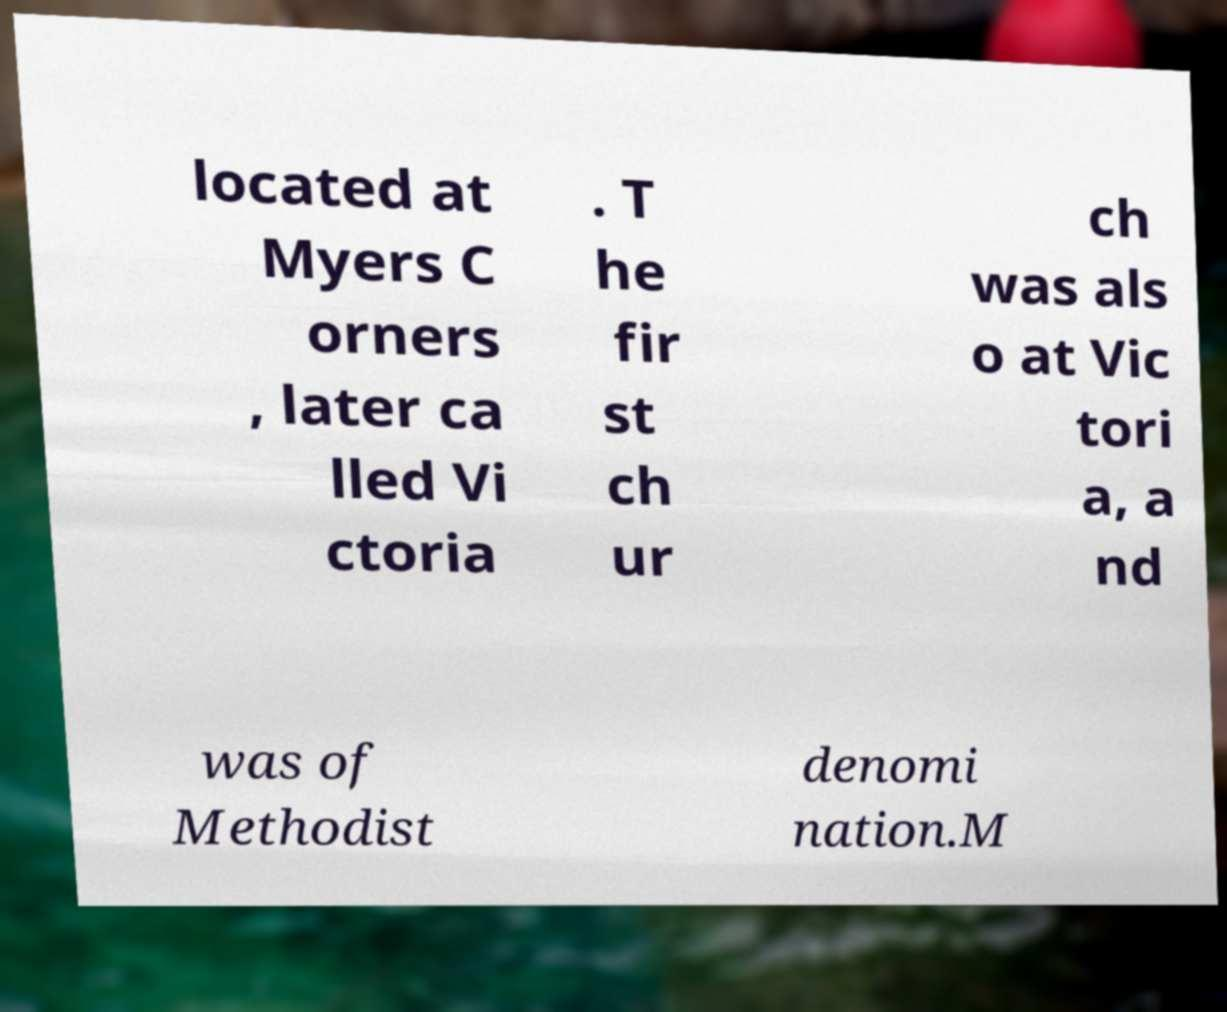There's text embedded in this image that I need extracted. Can you transcribe it verbatim? located at Myers C orners , later ca lled Vi ctoria . T he fir st ch ur ch was als o at Vic tori a, a nd was of Methodist denomi nation.M 